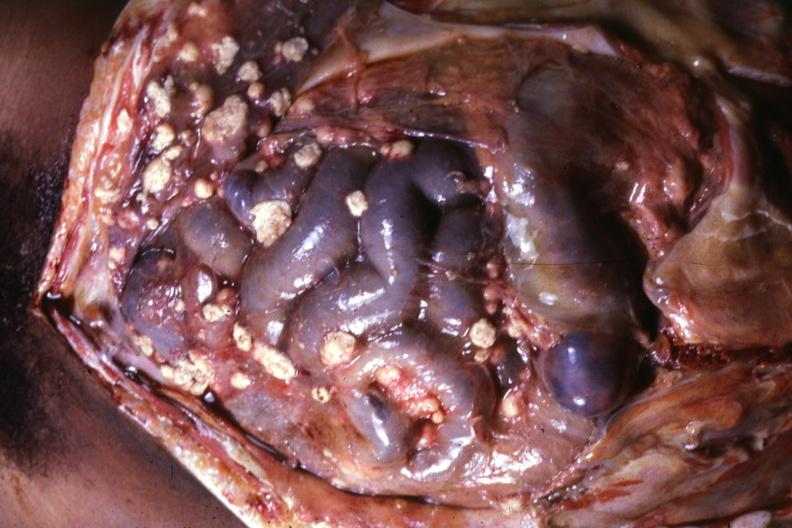does this image show opened abdominal cavity with atypically large lesions looking more like metastatic carcinoma?
Answer the question using a single word or phrase. Yes 